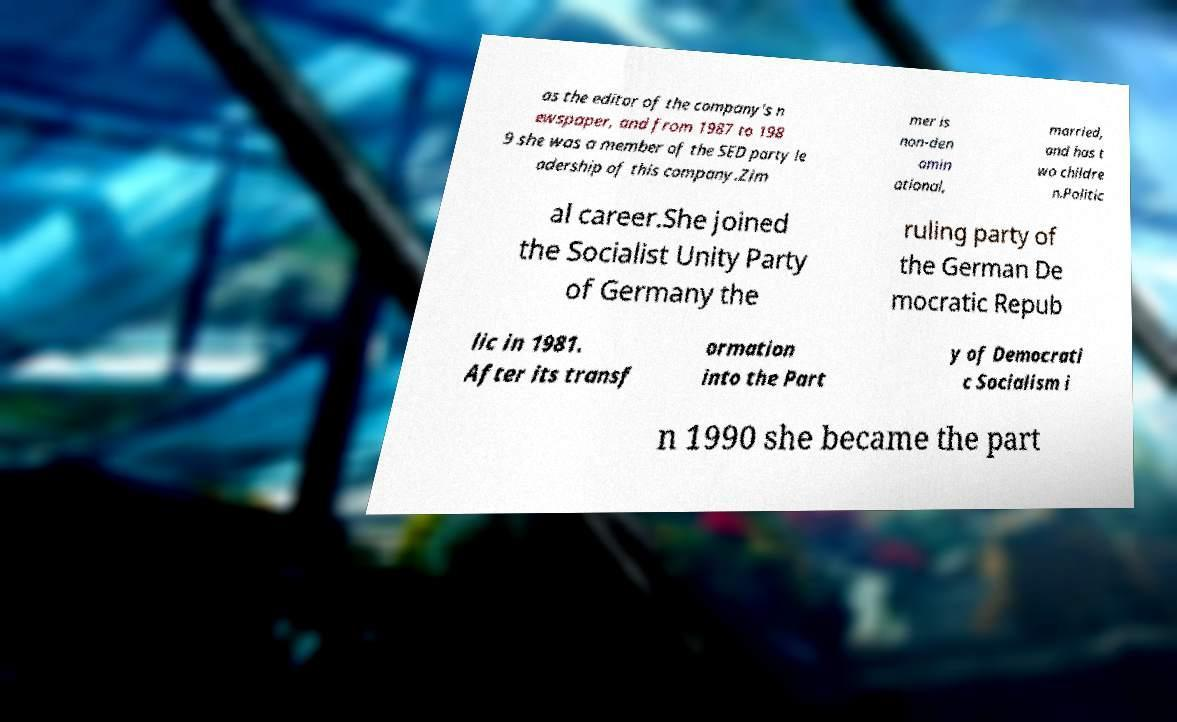What messages or text are displayed in this image? I need them in a readable, typed format. as the editor of the company's n ewspaper, and from 1987 to 198 9 she was a member of the SED party le adership of this company.Zim mer is non-den omin ational, married, and has t wo childre n.Politic al career.She joined the Socialist Unity Party of Germany the ruling party of the German De mocratic Repub lic in 1981. After its transf ormation into the Part y of Democrati c Socialism i n 1990 she became the part 